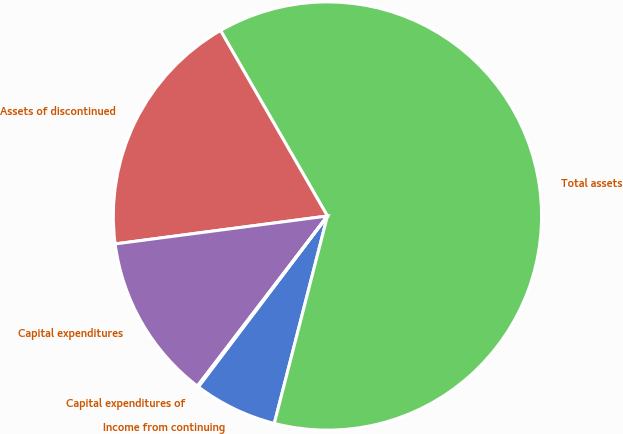<chart> <loc_0><loc_0><loc_500><loc_500><pie_chart><fcel>Income from continuing<fcel>Total assets<fcel>Assets of discontinued<fcel>Capital expenditures<fcel>Capital expenditures of<nl><fcel>6.31%<fcel>62.31%<fcel>18.76%<fcel>12.53%<fcel>0.09%<nl></chart> 